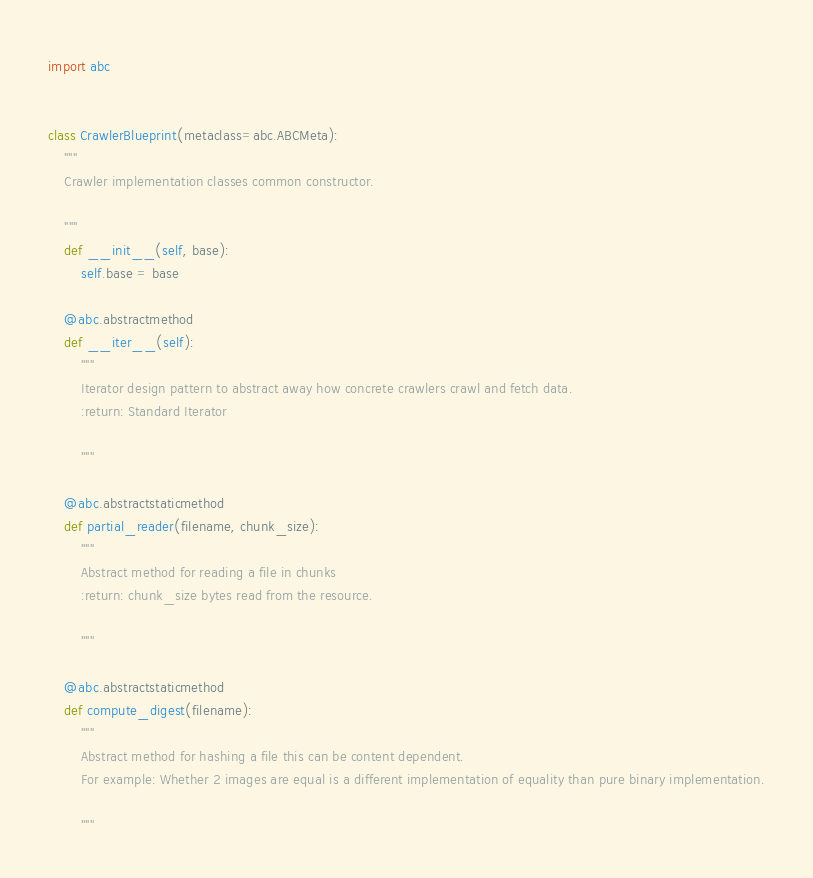Convert code to text. <code><loc_0><loc_0><loc_500><loc_500><_Python_>import abc


class CrawlerBlueprint(metaclass=abc.ABCMeta):
    """
    Crawler implementation classes common constructor.

    """
    def __init__(self, base):
        self.base = base

    @abc.abstractmethod
    def __iter__(self):
        """
        Iterator design pattern to abstract away how concrete crawlers crawl and fetch data.
        :return: Standard Iterator 

        """

    @abc.abstractstaticmethod
    def partial_reader(filename, chunk_size):
        """
        Abstract method for reading a file in chunks
        :return: chunk_size bytes read from the resource.

        """

    @abc.abstractstaticmethod
    def compute_digest(filename):
        """
        Abstract method for hashing a file this can be content dependent.
        For example: Whether 2 images are equal is a different implementation of equality than pure binary implementation.

        """
</code> 